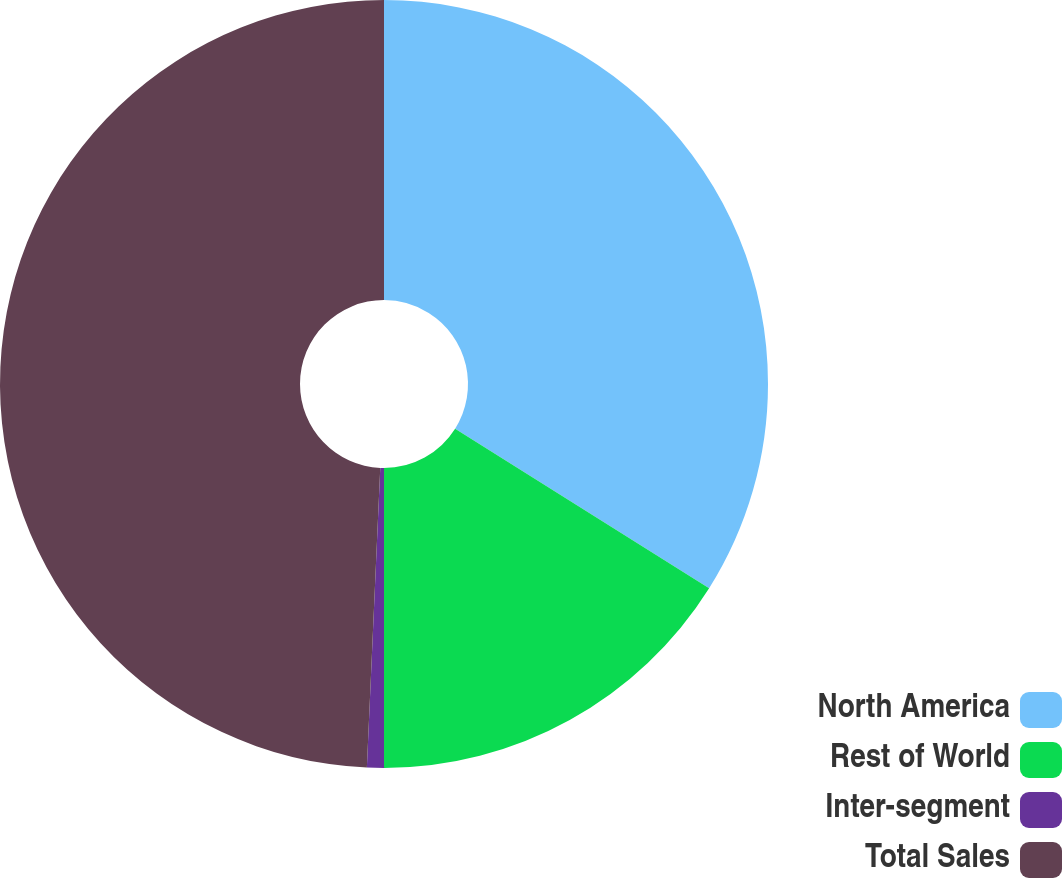<chart> <loc_0><loc_0><loc_500><loc_500><pie_chart><fcel>North America<fcel>Rest of World<fcel>Inter-segment<fcel>Total Sales<nl><fcel>33.93%<fcel>16.07%<fcel>0.71%<fcel>49.29%<nl></chart> 